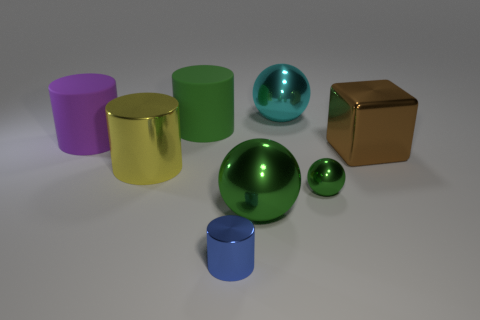Add 1 tiny brown cubes. How many objects exist? 9 Subtract all cubes. How many objects are left? 7 Subtract 1 yellow cylinders. How many objects are left? 7 Subtract all big green metallic objects. Subtract all yellow cylinders. How many objects are left? 6 Add 2 green metallic spheres. How many green metallic spheres are left? 4 Add 4 matte cylinders. How many matte cylinders exist? 6 